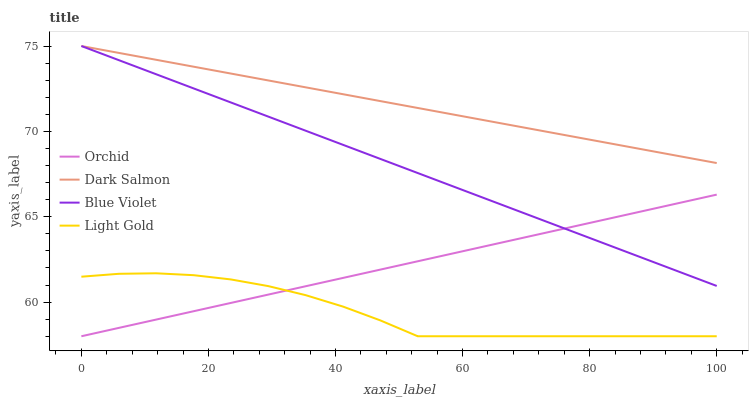Does Light Gold have the minimum area under the curve?
Answer yes or no. Yes. Does Dark Salmon have the maximum area under the curve?
Answer yes or no. Yes. Does Blue Violet have the minimum area under the curve?
Answer yes or no. No. Does Blue Violet have the maximum area under the curve?
Answer yes or no. No. Is Blue Violet the smoothest?
Answer yes or no. Yes. Is Light Gold the roughest?
Answer yes or no. Yes. Is Dark Salmon the smoothest?
Answer yes or no. No. Is Dark Salmon the roughest?
Answer yes or no. No. Does Light Gold have the lowest value?
Answer yes or no. Yes. Does Blue Violet have the lowest value?
Answer yes or no. No. Does Blue Violet have the highest value?
Answer yes or no. Yes. Does Orchid have the highest value?
Answer yes or no. No. Is Light Gold less than Dark Salmon?
Answer yes or no. Yes. Is Dark Salmon greater than Orchid?
Answer yes or no. Yes. Does Dark Salmon intersect Blue Violet?
Answer yes or no. Yes. Is Dark Salmon less than Blue Violet?
Answer yes or no. No. Is Dark Salmon greater than Blue Violet?
Answer yes or no. No. Does Light Gold intersect Dark Salmon?
Answer yes or no. No. 